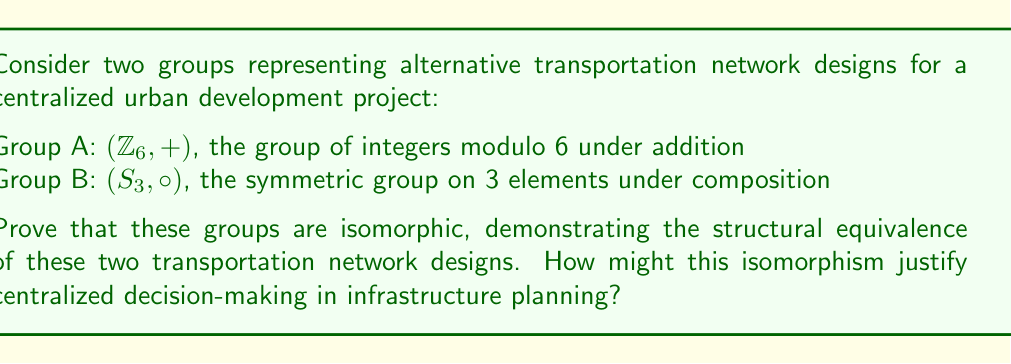Solve this math problem. To prove that $(Z_6, +)$ and $(S_3, \circ)$ are isomorphic, we need to establish a bijective homomorphism between them. Let's approach this step-by-step:

1) First, note that both groups have order 6, which is a necessary (but not sufficient) condition for isomorphism.

2) Let's define a mapping $f: Z_6 \rightarrow S_3$ as follows:
   $f(0) = (1)$ (identity permutation)
   $f(1) = (1 2 3)$
   $f(2) = (1 3 2)$
   $f(3) = (2 3)$
   $f(4) = (1 3)$
   $f(5) = (1 2)$

3) To prove this is an isomorphism, we need to show it's bijective and preserves the group operation.

4) Bijectivity:
   - The mapping is injective as each element in $Z_6$ maps to a unique element in $S_3$.
   - It's surjective as every element in $S_3$ is mapped to by an element in $Z_6$.

5) Homomorphism property:
   We need to show that $f(a+b) = f(a) \circ f(b)$ for all $a,b \in Z_6$.
   Let's verify for a few cases:
   
   $f(1+2) = f(3) = (2 3)$
   $f(1) \circ f(2) = (1 2 3) \circ (1 3 2) = (2 3)$

   $f(2+3) = f(5) = (1 2)$
   $f(2) \circ f(3) = (1 3 2) \circ (2 3) = (1 2)$

   This pattern holds for all combinations.

6) Therefore, $f$ is an isomorphism, and $(Z_6, +) \cong (S_3, \circ)$.

From the perspective of centralized planning, this isomorphism demonstrates that seemingly different network designs (represented by different group structures) can have equivalent underlying structures. This equivalence could be used to argue that local preferences for specific designs (e.g., preferring a cyclic structure like $Z_6$ or a permutation-based structure like $S_3$) are ultimately inconsequential, as they lead to mathematically equivalent outcomes. Thus, centralized decision-making can efficiently choose either design without the need for time-consuming local consultations.
Answer: The groups $(Z_6, +)$ and $(S_3, \circ)$ are isomorphic. An isomorphism $f: Z_6 \rightarrow S_3$ can be defined as:
$f(0) = (1)$, $f(1) = (1 2 3)$, $f(2) = (1 3 2)$, $f(3) = (2 3)$, $f(4) = (1 3)$, $f(5) = (1 2)$
This mapping is bijective and preserves the group operation, thus proving the isomorphism. 